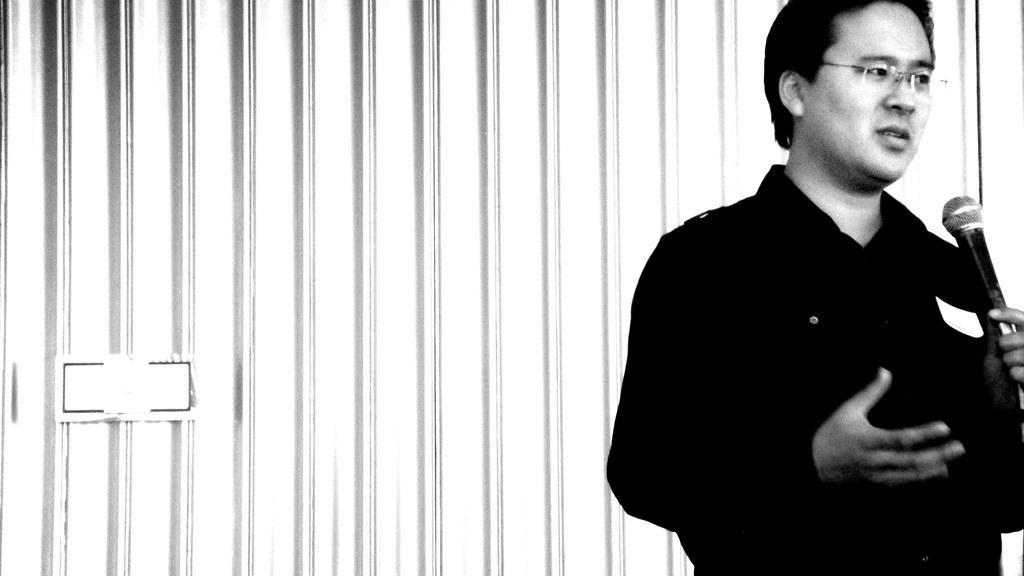Please provide a concise description of this image. This is a black and white image. We can see a person wearing spectacles is holding a microphone. We can see the wall with an object on it. 